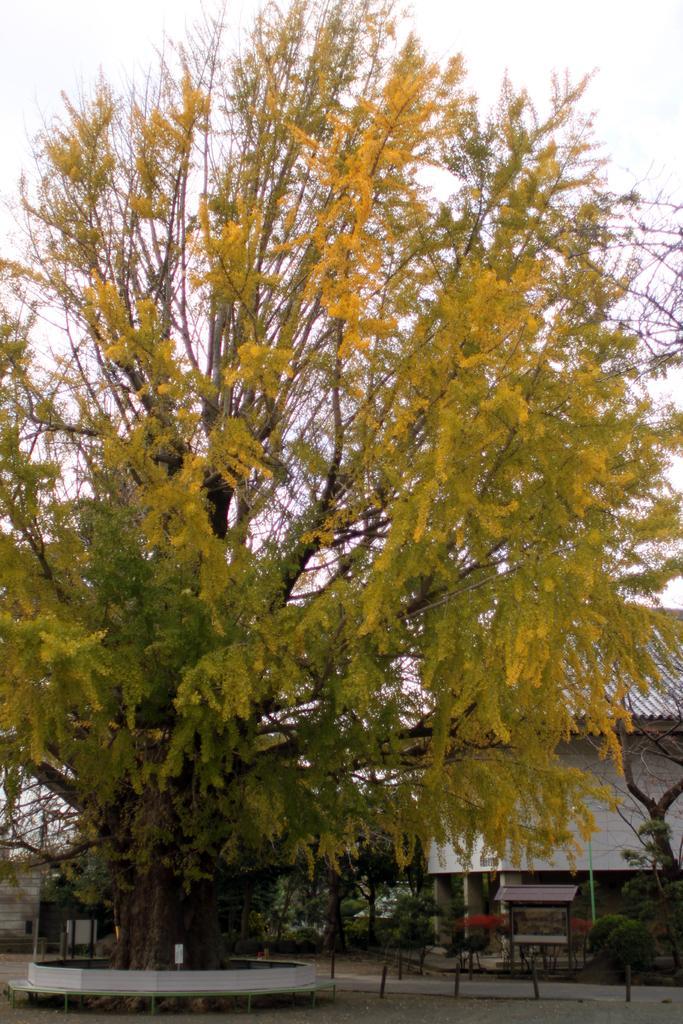Can you describe this image briefly? Here we can see tree. Background we can see roof top,plants and sky. 